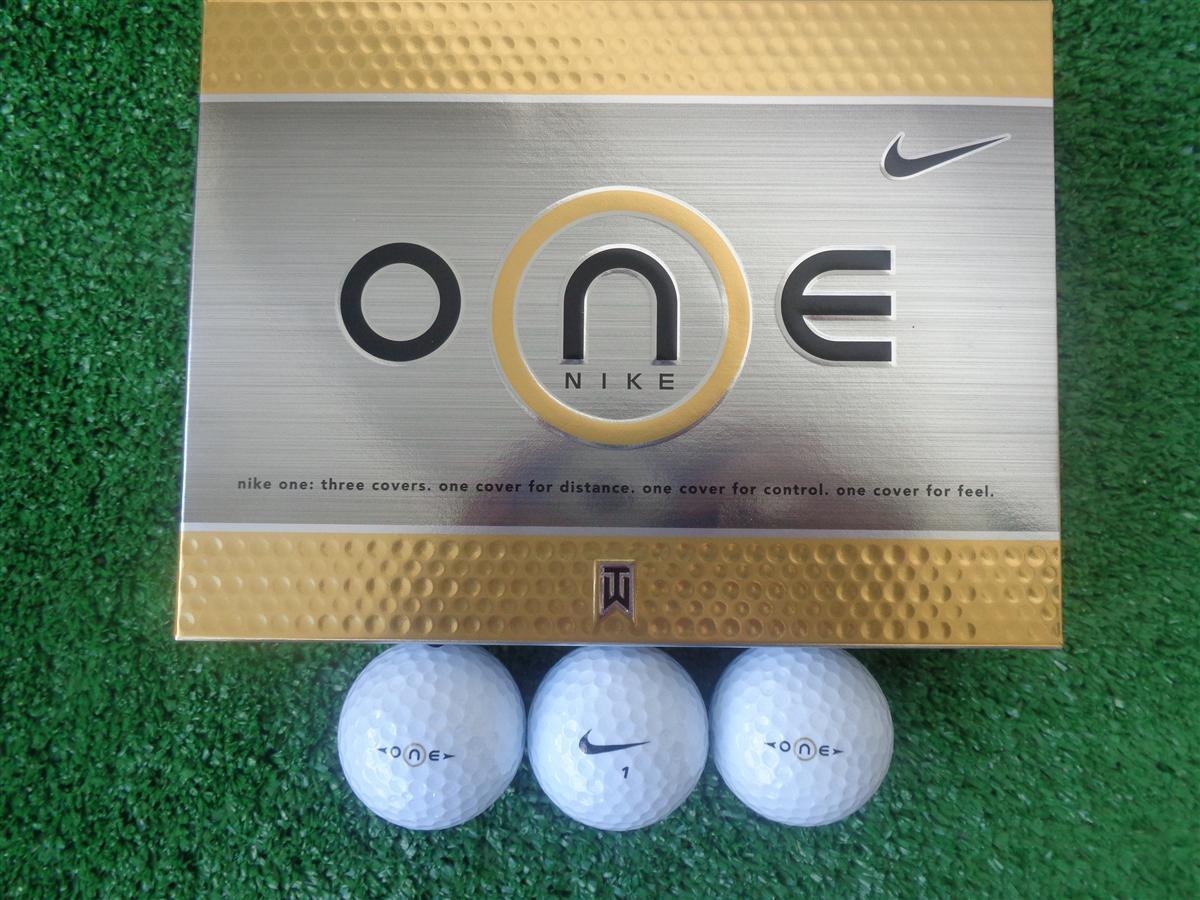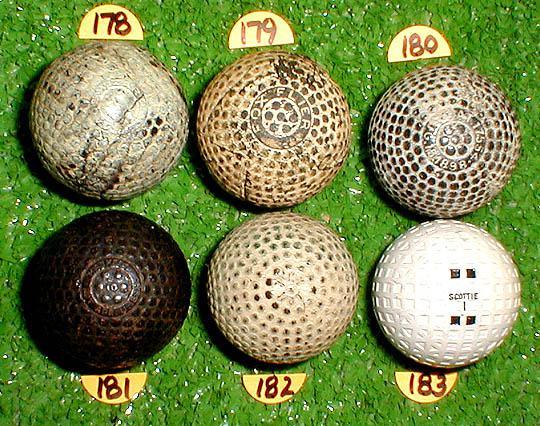The first image is the image on the left, the second image is the image on the right. Assess this claim about the two images: "There are three golf balls in the left image and one in the right.". Correct or not? Answer yes or no. No. The first image is the image on the left, the second image is the image on the right. Assess this claim about the two images: "The left image features three white golf balls in a straight row under a silver box with gold trim.". Correct or not? Answer yes or no. Yes. 